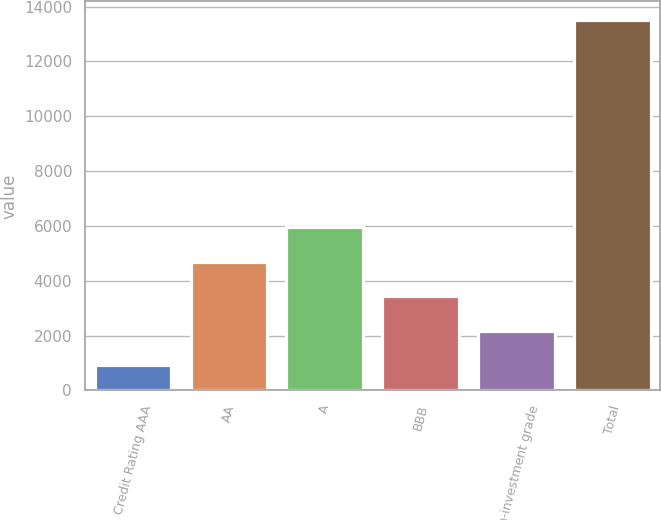Convert chart to OTSL. <chart><loc_0><loc_0><loc_500><loc_500><bar_chart><fcel>Credit Rating AAA<fcel>AA<fcel>A<fcel>BBB<fcel>Non-investment grade<fcel>Total<nl><fcel>918<fcel>4695.9<fcel>5955.2<fcel>3436.6<fcel>2177.3<fcel>13511<nl></chart> 